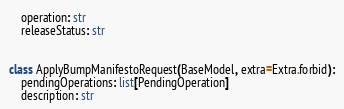Convert code to text. <code><loc_0><loc_0><loc_500><loc_500><_Python_>    operation: str
    releaseStatus: str


class ApplyBumpManifestoRequest(BaseModel, extra=Extra.forbid):
    pendingOperations: list[PendingOperation]
    description: str
</code> 